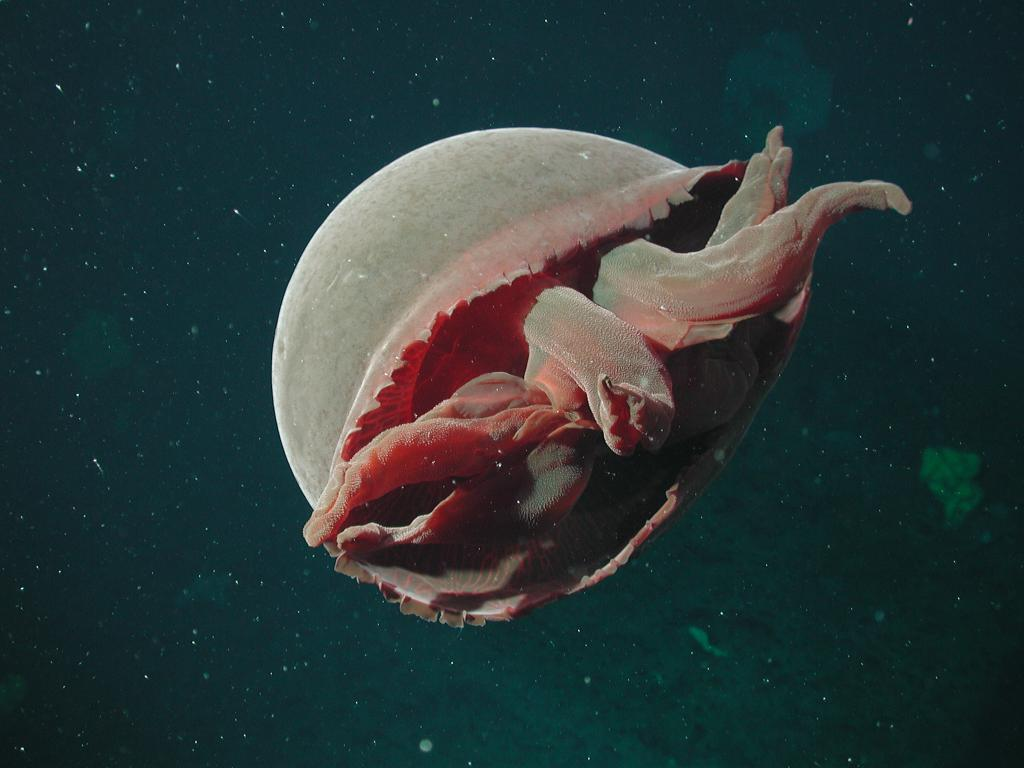What type of environment is shown in the image? The image depicts an underground water environment. What creature can be seen in the image? There is a jellyfish in the image. Can you see any crayons being used to draw in the image? There are no crayons or drawing activity present in the image, as it depicts an underground water environment with a jellyfish. 